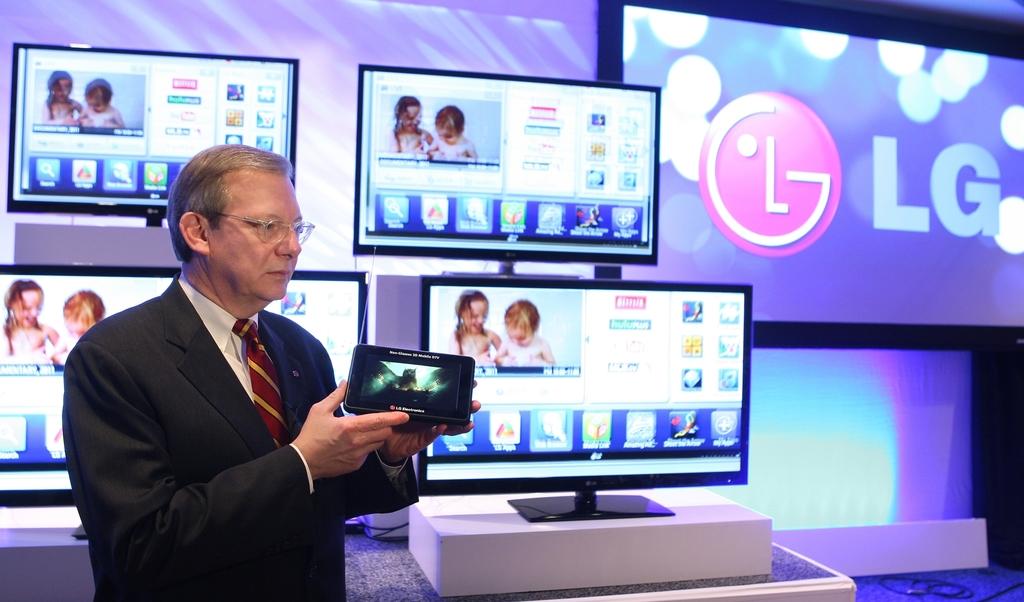What brand of tv is in the background?
Provide a succinct answer. Lg. What kind of electronics are shown in the background of this photo?
Ensure brevity in your answer.  Lg. 